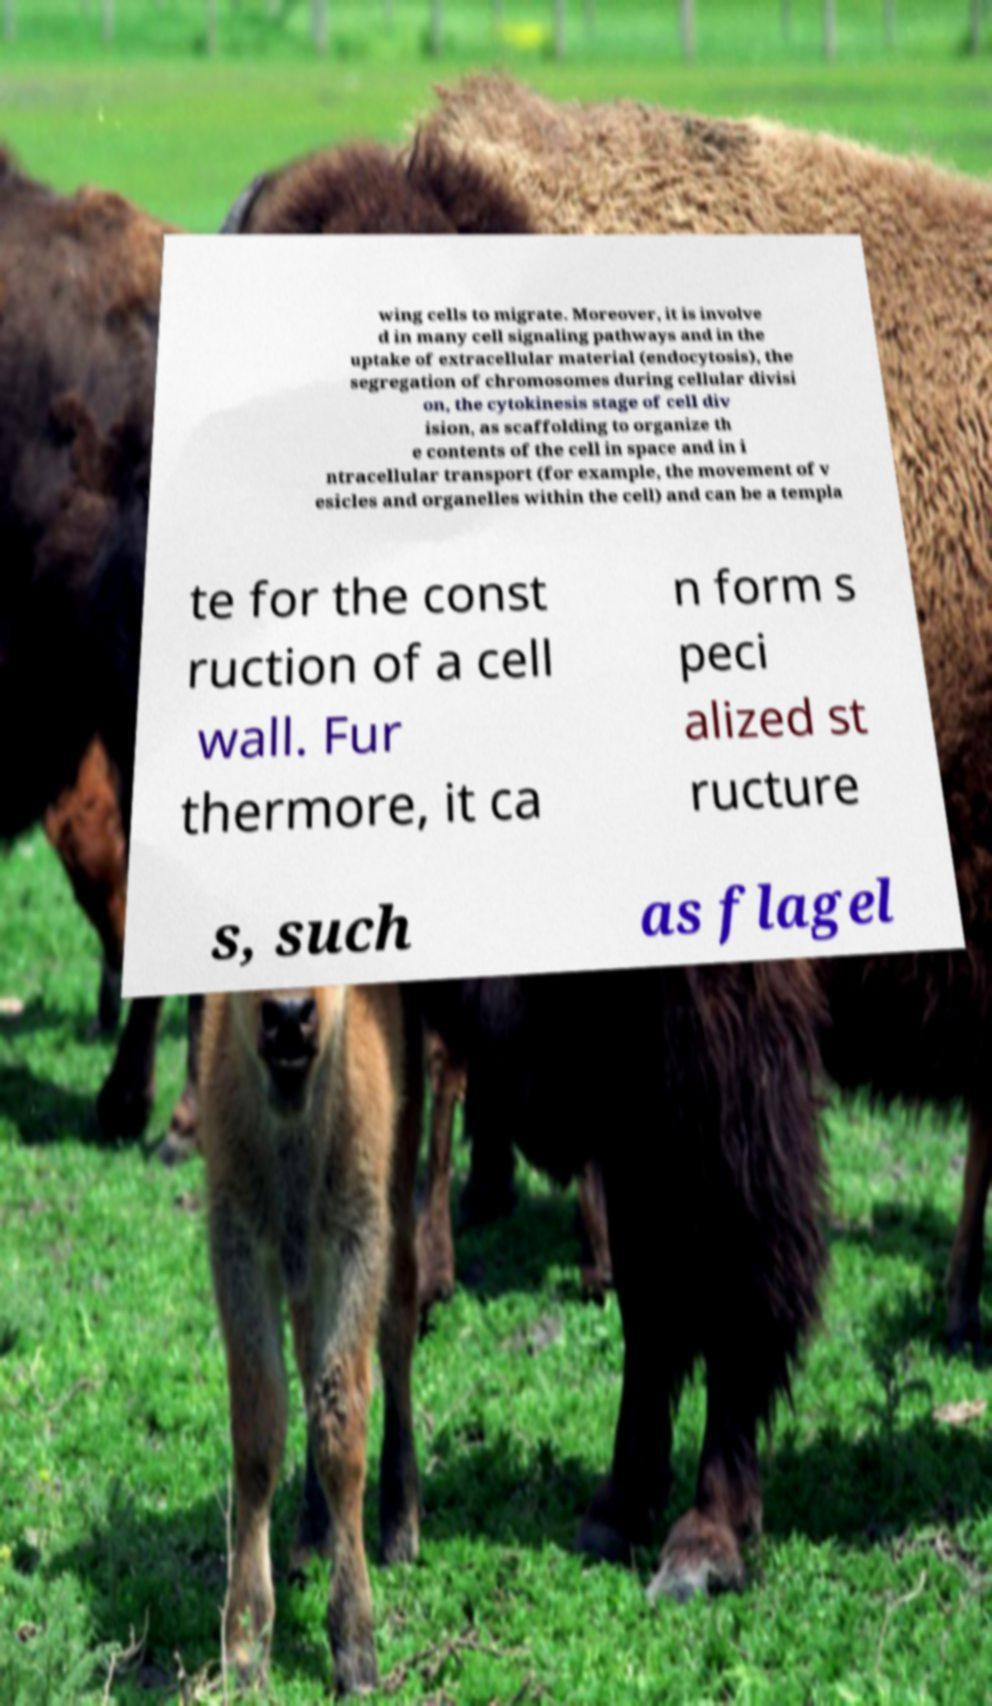Could you extract and type out the text from this image? wing cells to migrate. Moreover, it is involve d in many cell signaling pathways and in the uptake of extracellular material (endocytosis), the segregation of chromosomes during cellular divisi on, the cytokinesis stage of cell div ision, as scaffolding to organize th e contents of the cell in space and in i ntracellular transport (for example, the movement of v esicles and organelles within the cell) and can be a templa te for the const ruction of a cell wall. Fur thermore, it ca n form s peci alized st ructure s, such as flagel 